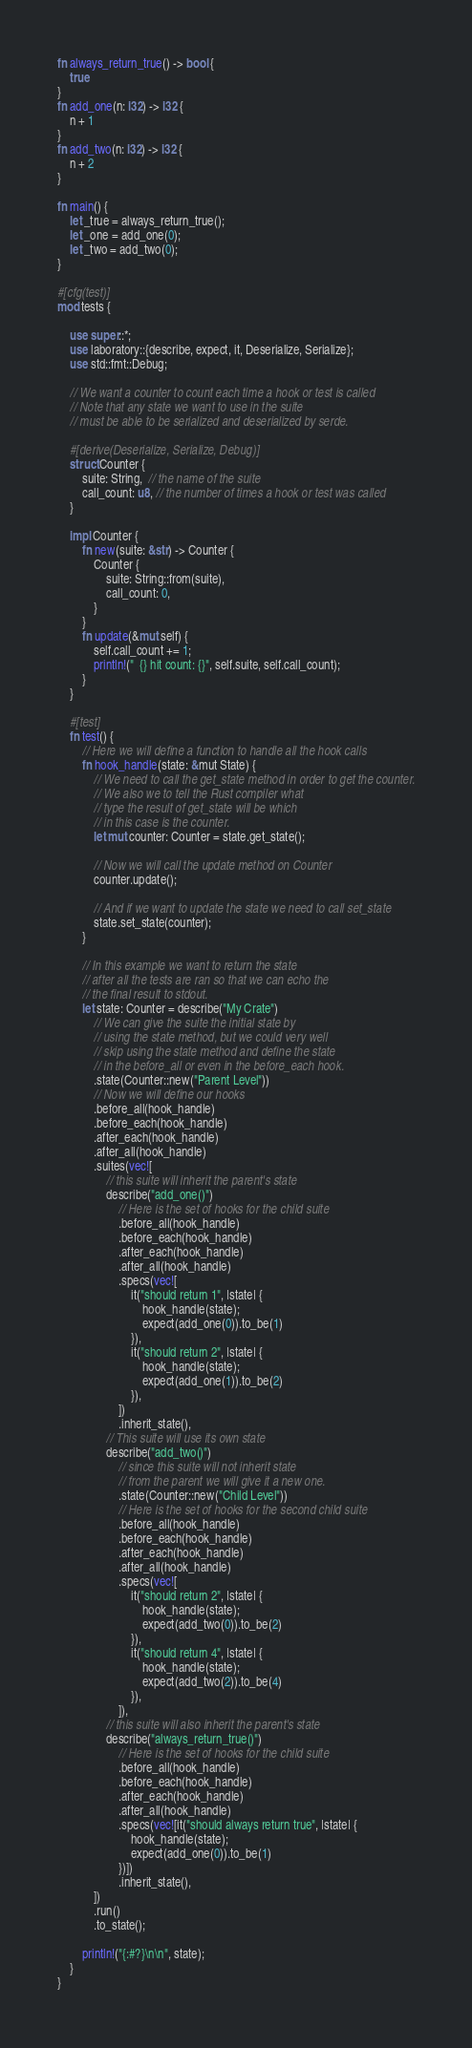<code> <loc_0><loc_0><loc_500><loc_500><_Rust_>fn always_return_true() -> bool {
    true
}
fn add_one(n: i32) -> i32 {
    n + 1
}
fn add_two(n: i32) -> i32 {
    n + 2
}

fn main() {
    let _true = always_return_true();
    let _one = add_one(0);
    let _two = add_two(0);
}

#[cfg(test)]
mod tests {

    use super::*;
    use laboratory::{describe, expect, it, Deserialize, Serialize};
    use std::fmt::Debug;

    // We want a counter to count each time a hook or test is called
    // Note that any state we want to use in the suite
    // must be able to be serialized and deserialized by serde.

    #[derive(Deserialize, Serialize, Debug)]
    struct Counter {
        suite: String,  // the name of the suite
        call_count: u8, // the number of times a hook or test was called
    }

    impl Counter {
        fn new(suite: &str) -> Counter {
            Counter {
                suite: String::from(suite),
                call_count: 0,
            }
        }
        fn update(&mut self) {
            self.call_count += 1;
            println!("  {} hit count: {}", self.suite, self.call_count);
        }
    }

    #[test]
    fn test() {
        // Here we will define a function to handle all the hook calls
        fn hook_handle(state: &mut State) {
            // We need to call the get_state method in order to get the counter.
            // We also we to tell the Rust compiler what
            // type the result of get_state will be which
            // in this case is the counter.
            let mut counter: Counter = state.get_state();

            // Now we will call the update method on Counter
            counter.update();

            // And if we want to update the state we need to call set_state
            state.set_state(counter);
        }

        // In this example we want to return the state
        // after all the tests are ran so that we can echo the
        // the final result to stdout.
        let state: Counter = describe("My Crate")
            // We can give the suite the initial state by
            // using the state method, but we could very well
            // skip using the state method and define the state
            // in the before_all or even in the before_each hook.
            .state(Counter::new("Parent Level"))
            // Now we will define our hooks
            .before_all(hook_handle)
            .before_each(hook_handle)
            .after_each(hook_handle)
            .after_all(hook_handle)
            .suites(vec![
                // this suite will inherit the parent's state
                describe("add_one()")
                    // Here is the set of hooks for the child suite
                    .before_all(hook_handle)
                    .before_each(hook_handle)
                    .after_each(hook_handle)
                    .after_all(hook_handle)
                    .specs(vec![
                        it("should return 1", |state| {
                            hook_handle(state);
                            expect(add_one(0)).to_be(1)
                        }),
                        it("should return 2", |state| {
                            hook_handle(state);
                            expect(add_one(1)).to_be(2)
                        }),
                    ])
                    .inherit_state(),
                // This suite will use its own state
                describe("add_two()")
                    // since this suite will not inherit state
                    // from the parent we will give it a new one.
                    .state(Counter::new("Child Level"))
                    // Here is the set of hooks for the second child suite
                    .before_all(hook_handle)
                    .before_each(hook_handle)
                    .after_each(hook_handle)
                    .after_all(hook_handle)
                    .specs(vec![
                        it("should return 2", |state| {
                            hook_handle(state);
                            expect(add_two(0)).to_be(2)
                        }),
                        it("should return 4", |state| {
                            hook_handle(state);
                            expect(add_two(2)).to_be(4)
                        }),
                    ]),
                // this suite will also inherit the parent's state
                describe("always_return_true()")
                    // Here is the set of hooks for the child suite
                    .before_all(hook_handle)
                    .before_each(hook_handle)
                    .after_each(hook_handle)
                    .after_all(hook_handle)
                    .specs(vec![it("should always return true", |state| {
                        hook_handle(state);
                        expect(add_one(0)).to_be(1)
                    })])
                    .inherit_state(),
            ])
            .run()
            .to_state();

        println!("{:#?}\n\n", state);
    }
}
</code> 